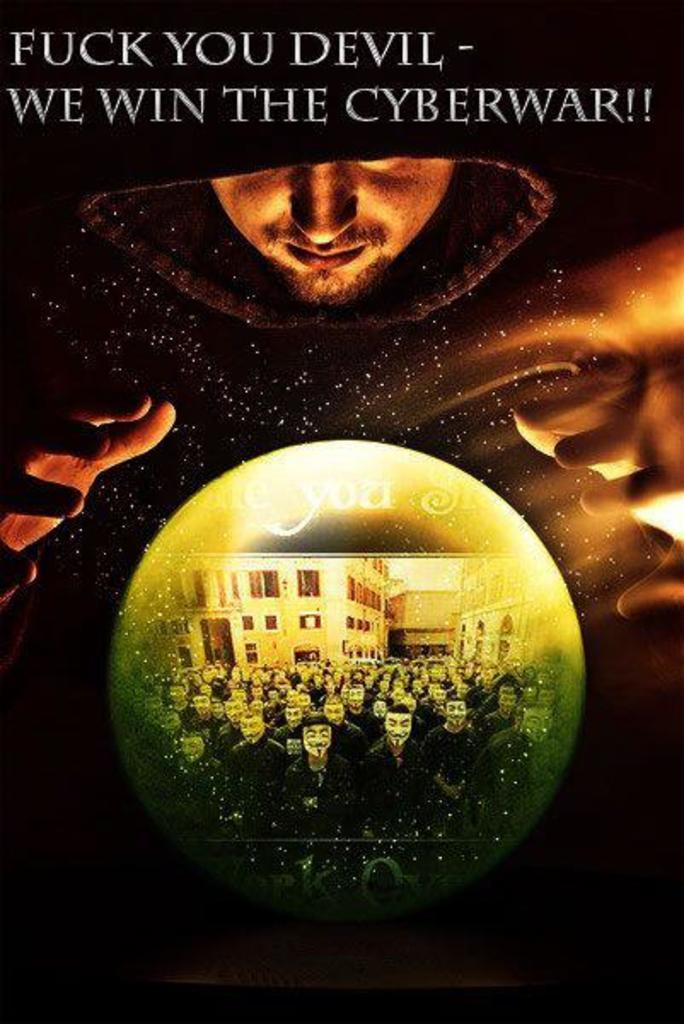<image>
Give a short and clear explanation of the subsequent image. Ad showing a man around a globe with the words "We Win the Cyberwar" on top. 